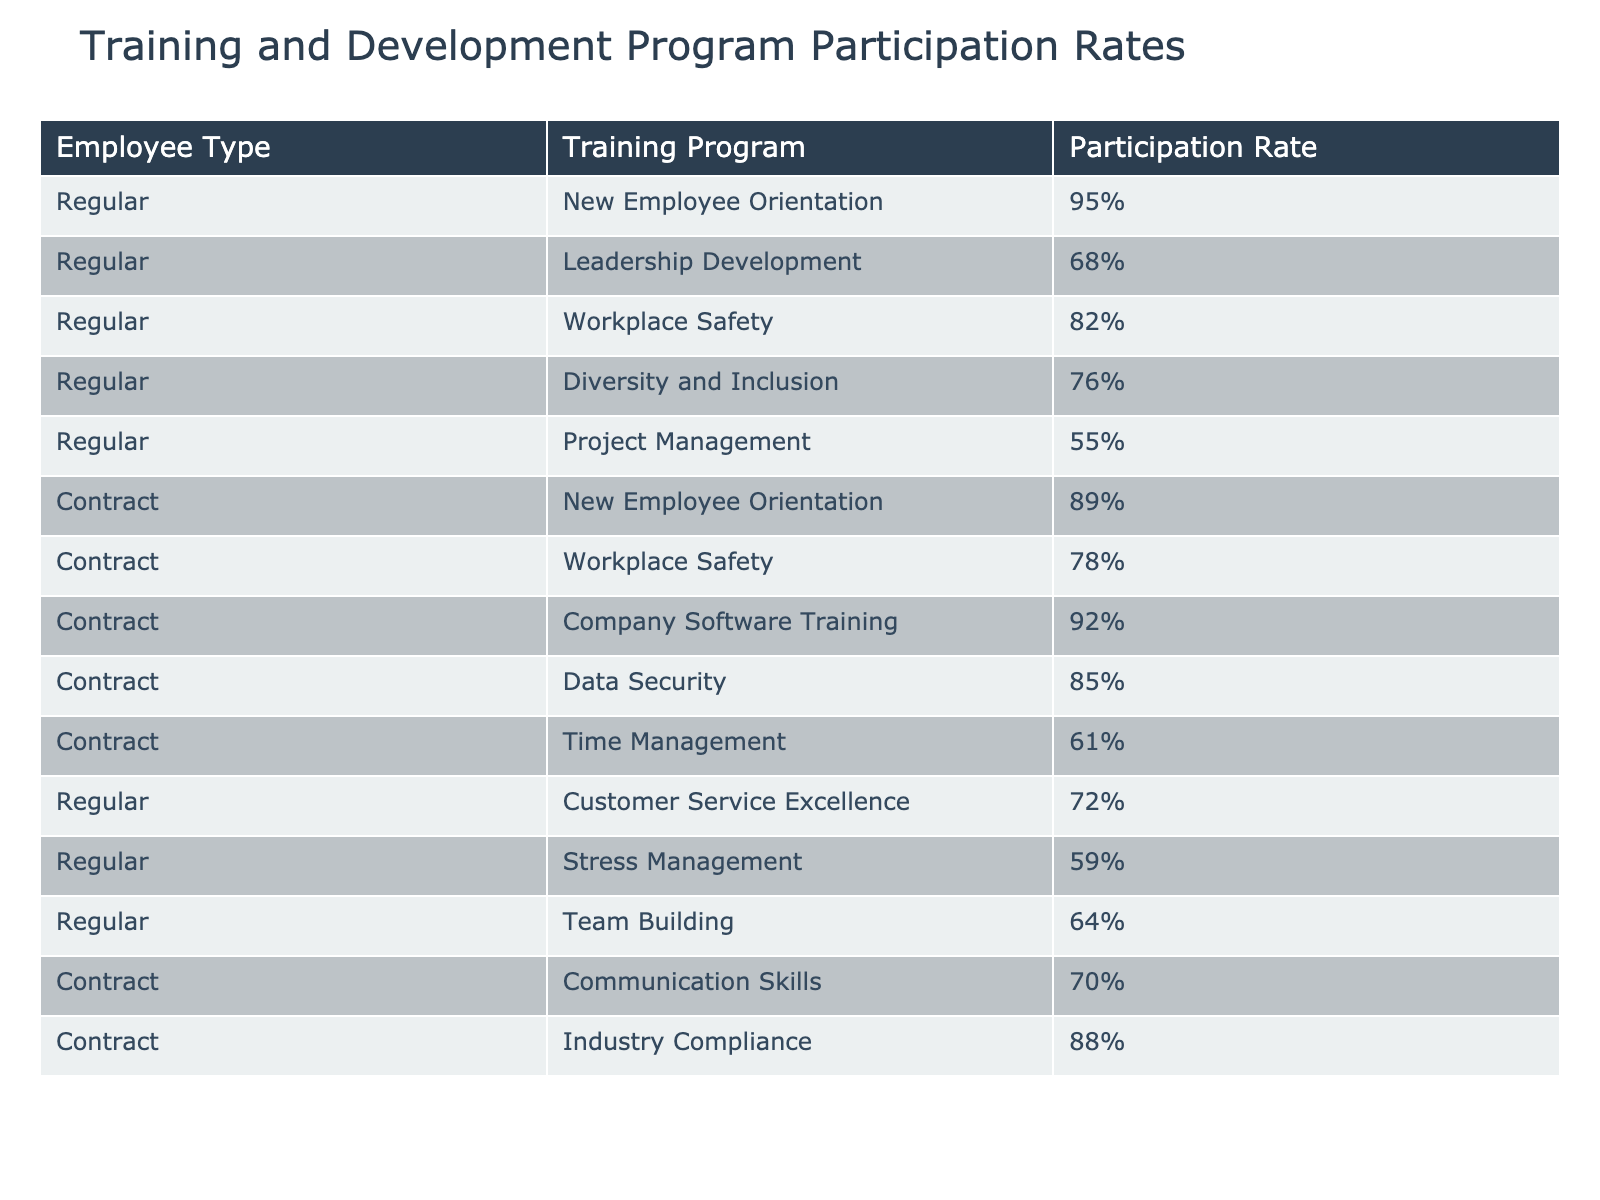What is the participation rate for the New Employee Orientation program for Regular employees? The table shows the participation rate for New Employee Orientation, which is listed under Regular employees with a value of 95%.
Answer: 95% What is the lowest participation rate among Contract employees? The table identifies the lowest participation rate among Contract employees. By reviewing the values, the lowest is for Time Management at 61%.
Answer: 61% Which training program has the highest participation rate for Regular employees? By examining the participation rates for Regular employees across all training programs, the one with the highest rate is New Employee Orientation, which stands at 95%.
Answer: 95% What is the average participation rate for all training programs available to Regular employees? The participation rates for Regular employees are 95%, 68%, 82%, 76%, 55%, 72%, 59%, and 64%. To find the average, we sum these rates (95 + 68 + 82 + 76 + 55 + 72 + 59 + 64 = 576), and then divide by the number of programs (8): 576 / 8 = 72.
Answer: 72% Is the participation rate for Company Software Training higher than the participation rate for Diversity and Inclusion? The participation rate for Company Software Training (Contract employees) is 92%, while for Diversity and Inclusion (Regular employees) it is 76%. Since 92% is greater than 76%, the statement is true.
Answer: Yes What is the difference in participation rate between the highest and lowest for Contract employees? The highest participation rate for Contract employees is Company Software Training at 92%, and the lowest is Time Management at 61%. To find the difference, we subtract the lowest from the highest: 92 - 61 = 31.
Answer: 31 How many training programs have a participation rate of 80% or more for Regular employees? Reviewing the rates for Regular employees, the programs that meet this criterion are New Employee Orientation (95%), Workplace Safety (82%), and Diversity and Inclusion (76%). Thus, there are a total of 3 programs with rates of 80% or more.
Answer: 2 Which type of employees generally have higher participation rates? By comparing the rates of the training programs for Regular and Contract employees, we can see that Regular employees have higher rates in most cases, particularly in New Employee Orientation. Thus, Regular employees generally have higher participation rates.
Answer: Regular employees What is the participation rate for Stress Management among Regular employees? The participation rate for Stress Management for Regular employees is clearly stated in the table, with a value of 59%.
Answer: 59% What is the total participation rate for all training programs combined for Contract employees? To calculate the total participation rate for Contract employees, we add their individual participation rates: 89 + 78 + 92 + 85 + 61 + 70 + 88 = 563. However, as it consists of multiple programs, we rather focus on individual expressions or check within the participation trend for collective summarization if necessary.
Answer: 563 